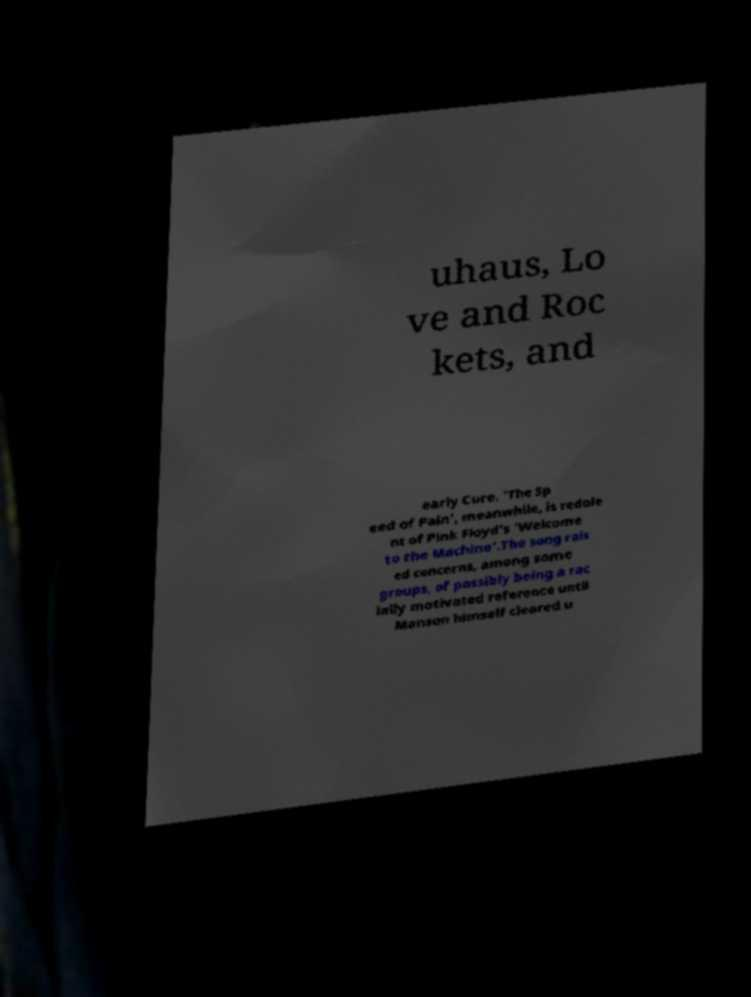Can you read and provide the text displayed in the image?This photo seems to have some interesting text. Can you extract and type it out for me? uhaus, Lo ve and Roc kets, and early Cure. 'The Sp eed of Pain', meanwhile, is redole nt of Pink Floyd's 'Welcome to the Machine'.The song rais ed concerns, among some groups, of possibly being a rac ially motivated reference until Manson himself cleared u 